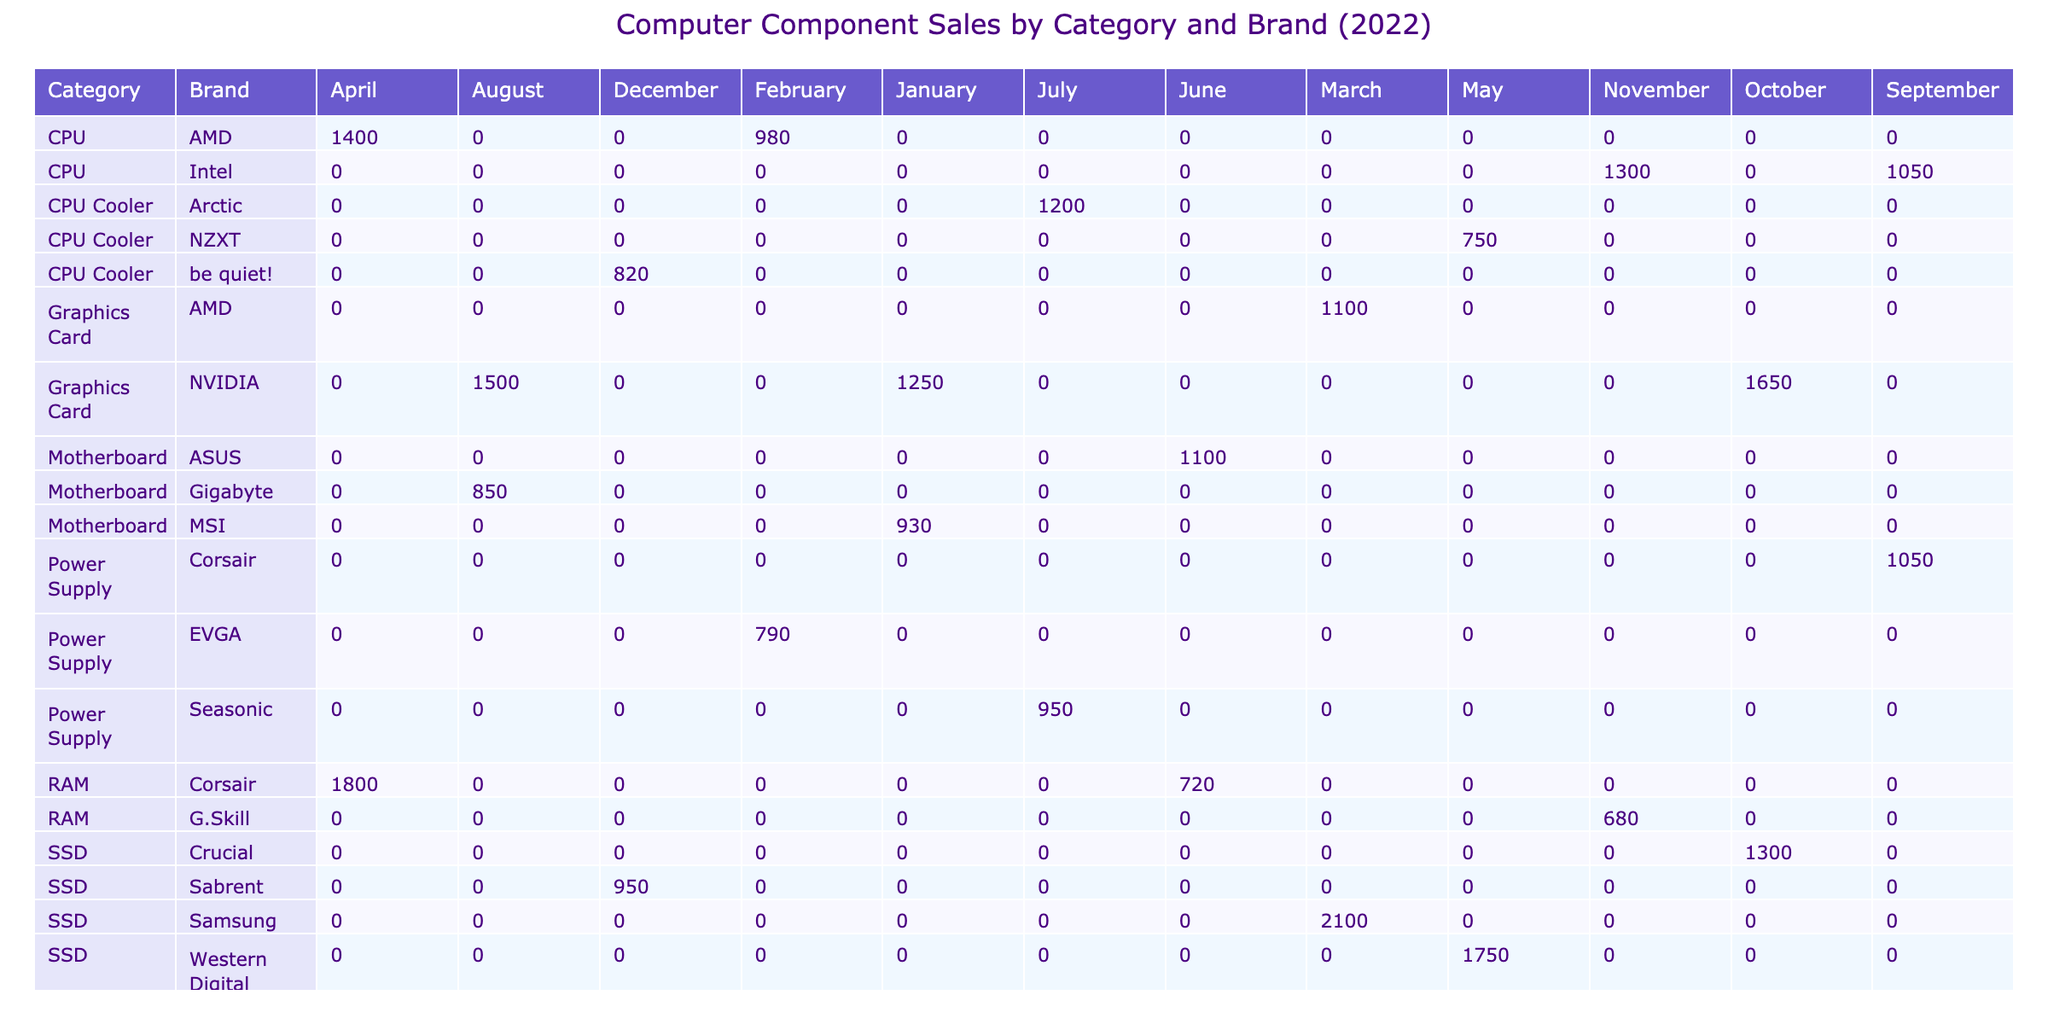What was the total number of units sold for NVIDIA graphics cards? To determine this, I need to find the rows that correspond to NVIDIA under the 'Category' of 'Graphics Card'. The units sold for GeForce RTX 3080 in January is 1250, and for GeForce RTX 3070 in August, it is 1500. Adding these together: 1250 + 1500 = 2750.
Answer: 2750 Which month had the highest units sold for RAM components? I will check the RAM category since it contains Corsair Vengeance RGB Pro 32GB and Corsair Dominator Platinum 32GB. The units sold are 1800 in April for the first and 720 in November for the second. April has the highest figure of 1800.
Answer: April Is the customer rating for AMD CPUs higher than the rating for Intel CPUs? Looking at the customer ratings for AMD, Ryzen 9 5950X has a rating of 4.9 and Ryzen 7 5800X has a rating of 4.8. For Intel, Core i9-12900K rates 4.8 and Core i7-12700K rates 4.8. Both AMD CPUs have higher or equal ratings compared to Intel CPUs.
Answer: Yes What is the average number of units sold for SSDs in 2022? There are three SSD entries: Samsung 970 EVO Plus 1TB sold 2100, Crucial P5 Plus 2TB sold 1300, and WD Black SN850 1TB sold 1750 units. The average is calculated as (2100 + 1300 + 1750) / 3 = 1716.67. Rounding gives 1717.
Answer: 1717 Which brand sold the most CPU Coolers combined across all months? I need to look for the total units sold of CPU coolers. There are two entries: NZXT Kraken X53 with 750 units in May and Arctic Freezer 34 eSports DUO with 1200 units in July. Adding these yields: 750 + 1200 = 1950. So, Arctic Freezer sold more units.
Answer: Arctic Freezer 34 eSports DUO How many units of graphics cards were sold in the month of October? The only entry for graphics cards in October is the GeForce RTX 3060 Ti, which sold 1650 units. Therefore, the total units sold in October for graphics cards is 1650.
Answer: 1650 What component had the lowest customer rating in December? The entries in December include be quiet! Dark Rock Pro 4 with 4.6 rating and Sabrent Rocket 4 Plus 2TB also with 4.6 rating. Since they are tied, they both had the lowest rating for December.
Answer: Both had 4.6 rating Summarize the total units sold by brand for RAM components. The total units sold for Corsair (1800 + 720) is 2520. G.Skill only has one entry of 680 units. Adding them together: 2520 for Corsair + 680 for G.Skill = 3200. Corsair is the dominant brand here.
Answer: 3200 